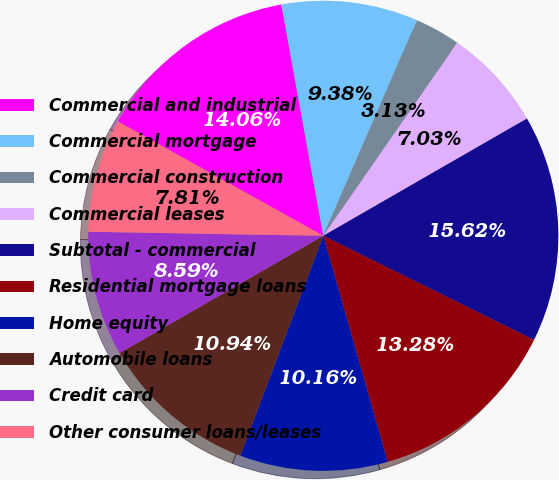<chart> <loc_0><loc_0><loc_500><loc_500><pie_chart><fcel>Commercial and industrial<fcel>Commercial mortgage<fcel>Commercial construction<fcel>Commercial leases<fcel>Subtotal - commercial<fcel>Residential mortgage loans<fcel>Home equity<fcel>Automobile loans<fcel>Credit card<fcel>Other consumer loans/leases<nl><fcel>14.06%<fcel>9.38%<fcel>3.13%<fcel>7.03%<fcel>15.62%<fcel>13.28%<fcel>10.16%<fcel>10.94%<fcel>8.59%<fcel>7.81%<nl></chart> 